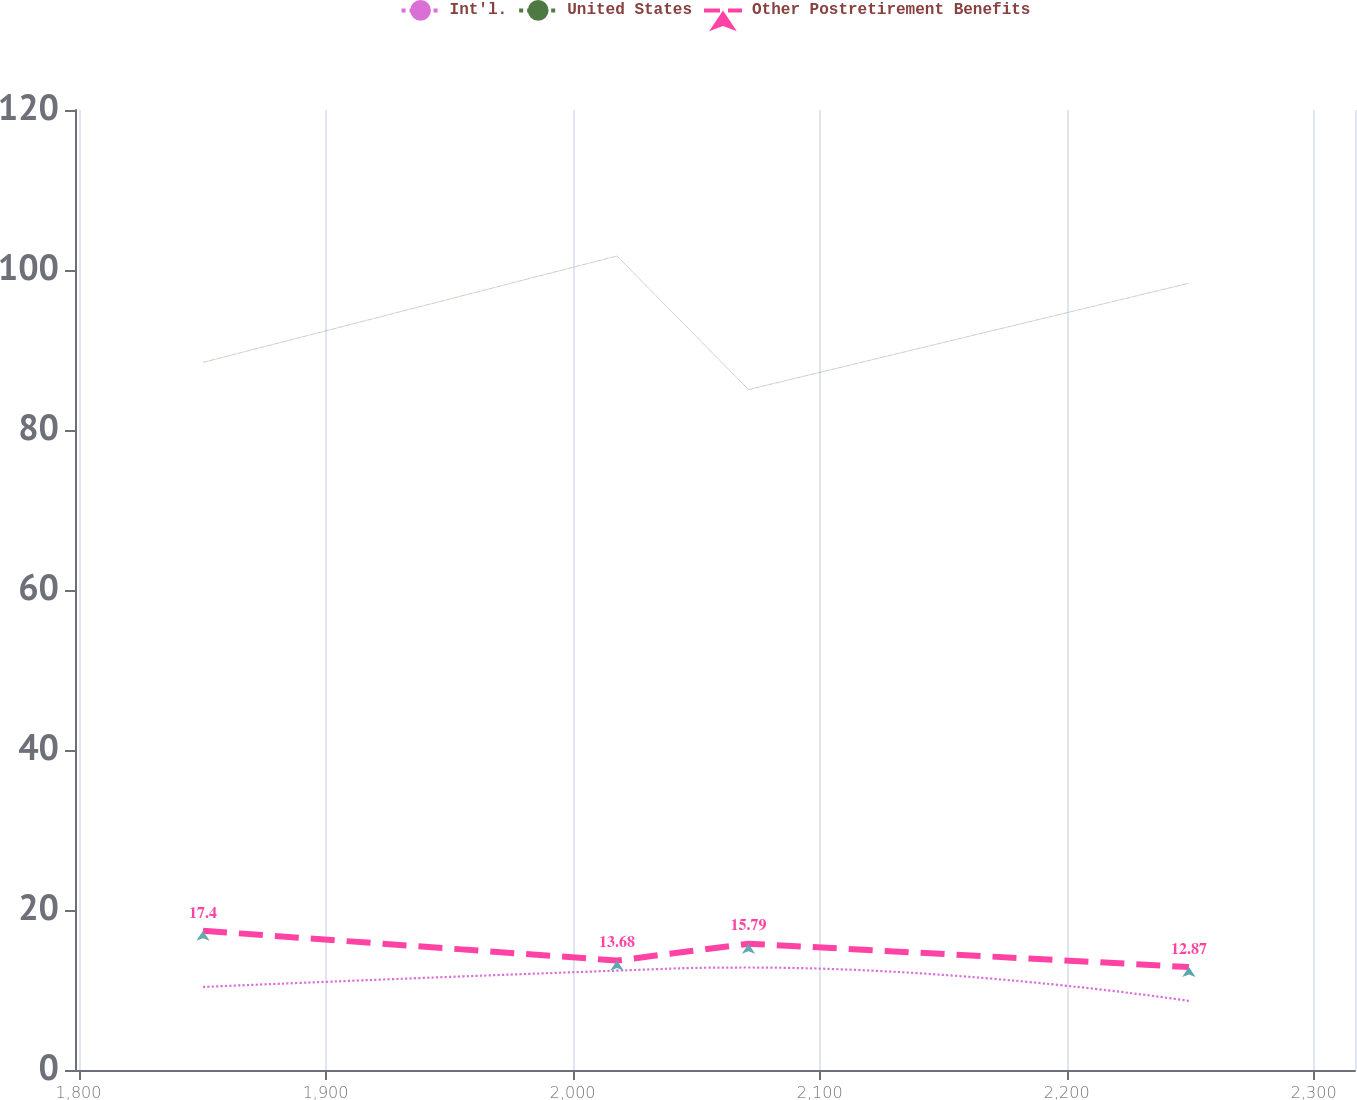Convert chart to OTSL. <chart><loc_0><loc_0><loc_500><loc_500><line_chart><ecel><fcel>Int'l.<fcel>United States<fcel>Other Postretirement Benefits<nl><fcel>1850.39<fcel>10.38<fcel>88.45<fcel>17.4<nl><fcel>2017.96<fcel>12.42<fcel>101.75<fcel>13.68<nl><fcel>2071.2<fcel>12.81<fcel>85.05<fcel>15.79<nl><fcel>2249.47<fcel>8.64<fcel>98.35<fcel>12.87<nl><fcel>2368.51<fcel>12.03<fcel>119.06<fcel>17.88<nl></chart> 